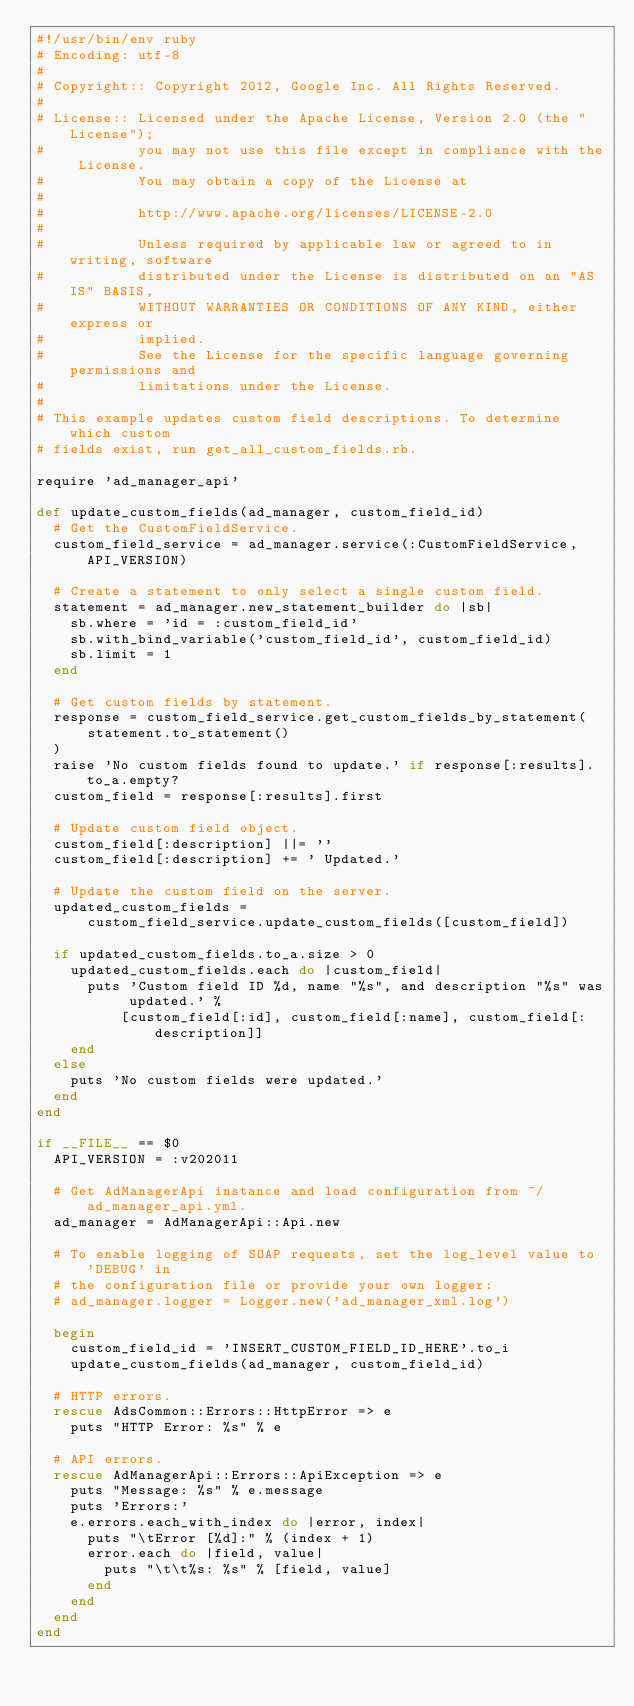Convert code to text. <code><loc_0><loc_0><loc_500><loc_500><_Ruby_>#!/usr/bin/env ruby
# Encoding: utf-8
#
# Copyright:: Copyright 2012, Google Inc. All Rights Reserved.
#
# License:: Licensed under the Apache License, Version 2.0 (the "License");
#           you may not use this file except in compliance with the License.
#           You may obtain a copy of the License at
#
#           http://www.apache.org/licenses/LICENSE-2.0
#
#           Unless required by applicable law or agreed to in writing, software
#           distributed under the License is distributed on an "AS IS" BASIS,
#           WITHOUT WARRANTIES OR CONDITIONS OF ANY KIND, either express or
#           implied.
#           See the License for the specific language governing permissions and
#           limitations under the License.
#
# This example updates custom field descriptions. To determine which custom
# fields exist, run get_all_custom_fields.rb.

require 'ad_manager_api'

def update_custom_fields(ad_manager, custom_field_id)
  # Get the CustomFieldService.
  custom_field_service = ad_manager.service(:CustomFieldService, API_VERSION)

  # Create a statement to only select a single custom field.
  statement = ad_manager.new_statement_builder do |sb|
    sb.where = 'id = :custom_field_id'
    sb.with_bind_variable('custom_field_id', custom_field_id)
    sb.limit = 1
  end

  # Get custom fields by statement.
  response = custom_field_service.get_custom_fields_by_statement(
      statement.to_statement()
  )
  raise 'No custom fields found to update.' if response[:results].to_a.empty?
  custom_field = response[:results].first

  # Update custom field object.
  custom_field[:description] ||= ''
  custom_field[:description] += ' Updated.'

  # Update the custom field on the server.
  updated_custom_fields =
      custom_field_service.update_custom_fields([custom_field])

  if updated_custom_fields.to_a.size > 0
    updated_custom_fields.each do |custom_field|
      puts 'Custom field ID %d, name "%s", and description "%s" was updated.' %
          [custom_field[:id], custom_field[:name], custom_field[:description]]
    end
  else
    puts 'No custom fields were updated.'
  end
end

if __FILE__ == $0
  API_VERSION = :v202011

  # Get AdManagerApi instance and load configuration from ~/ad_manager_api.yml.
  ad_manager = AdManagerApi::Api.new

  # To enable logging of SOAP requests, set the log_level value to 'DEBUG' in
  # the configuration file or provide your own logger:
  # ad_manager.logger = Logger.new('ad_manager_xml.log')

  begin
    custom_field_id = 'INSERT_CUSTOM_FIELD_ID_HERE'.to_i
    update_custom_fields(ad_manager, custom_field_id)

  # HTTP errors.
  rescue AdsCommon::Errors::HttpError => e
    puts "HTTP Error: %s" % e

  # API errors.
  rescue AdManagerApi::Errors::ApiException => e
    puts "Message: %s" % e.message
    puts 'Errors:'
    e.errors.each_with_index do |error, index|
      puts "\tError [%d]:" % (index + 1)
      error.each do |field, value|
        puts "\t\t%s: %s" % [field, value]
      end
    end
  end
end
</code> 